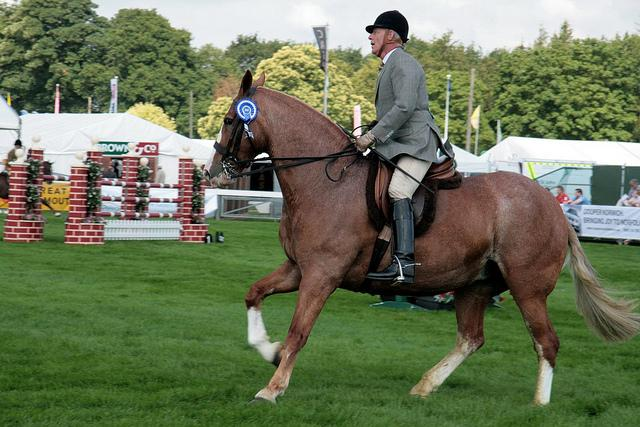What does the man have on? Please explain your reasoning. hat. The man has a hat on his head. 